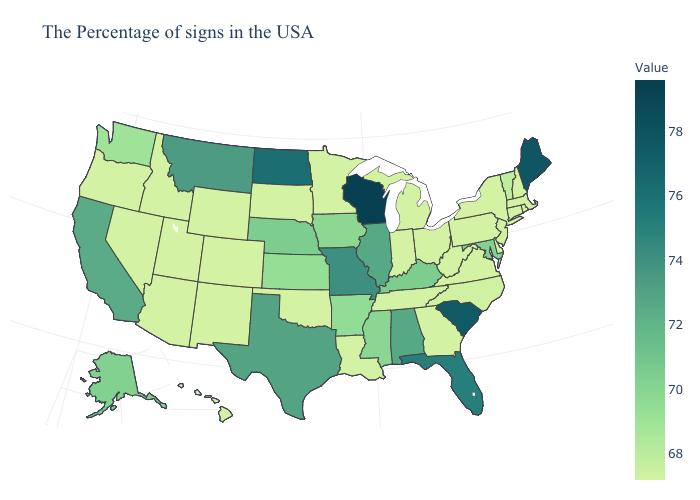Which states have the highest value in the USA?
Keep it brief. Wisconsin. Does Rhode Island have the lowest value in the Northeast?
Write a very short answer. No. Among the states that border Pennsylvania , does Maryland have the highest value?
Concise answer only. Yes. Among the states that border Utah , which have the lowest value?
Concise answer only. Wyoming, Colorado, New Mexico, Arizona, Idaho, Nevada. Does Kansas have a higher value than Montana?
Give a very brief answer. No. Among the states that border Texas , does Oklahoma have the lowest value?
Write a very short answer. Yes. Does Michigan have the lowest value in the MidWest?
Short answer required. Yes. Which states hav the highest value in the Northeast?
Keep it brief. Maine. 